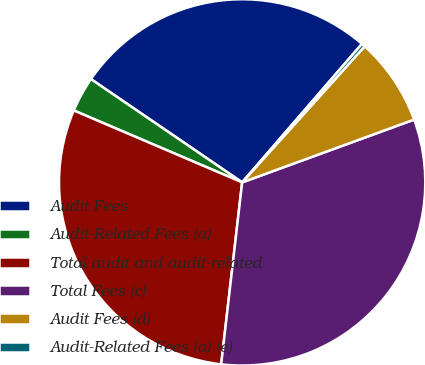Convert chart. <chart><loc_0><loc_0><loc_500><loc_500><pie_chart><fcel>Audit Fees<fcel>Audit-Related Fees (a)<fcel>Total audit and audit-related<fcel>Total Fees (c)<fcel>Audit Fees (d)<fcel>Audit-Related Fees (a) (e)<nl><fcel>26.81%<fcel>3.11%<fcel>29.6%<fcel>32.4%<fcel>7.76%<fcel>0.32%<nl></chart> 